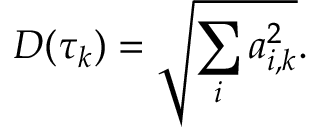<formula> <loc_0><loc_0><loc_500><loc_500>D ( \tau _ { k } ) = \sqrt { \sum _ { i } a _ { i , k } ^ { 2 } } .</formula> 